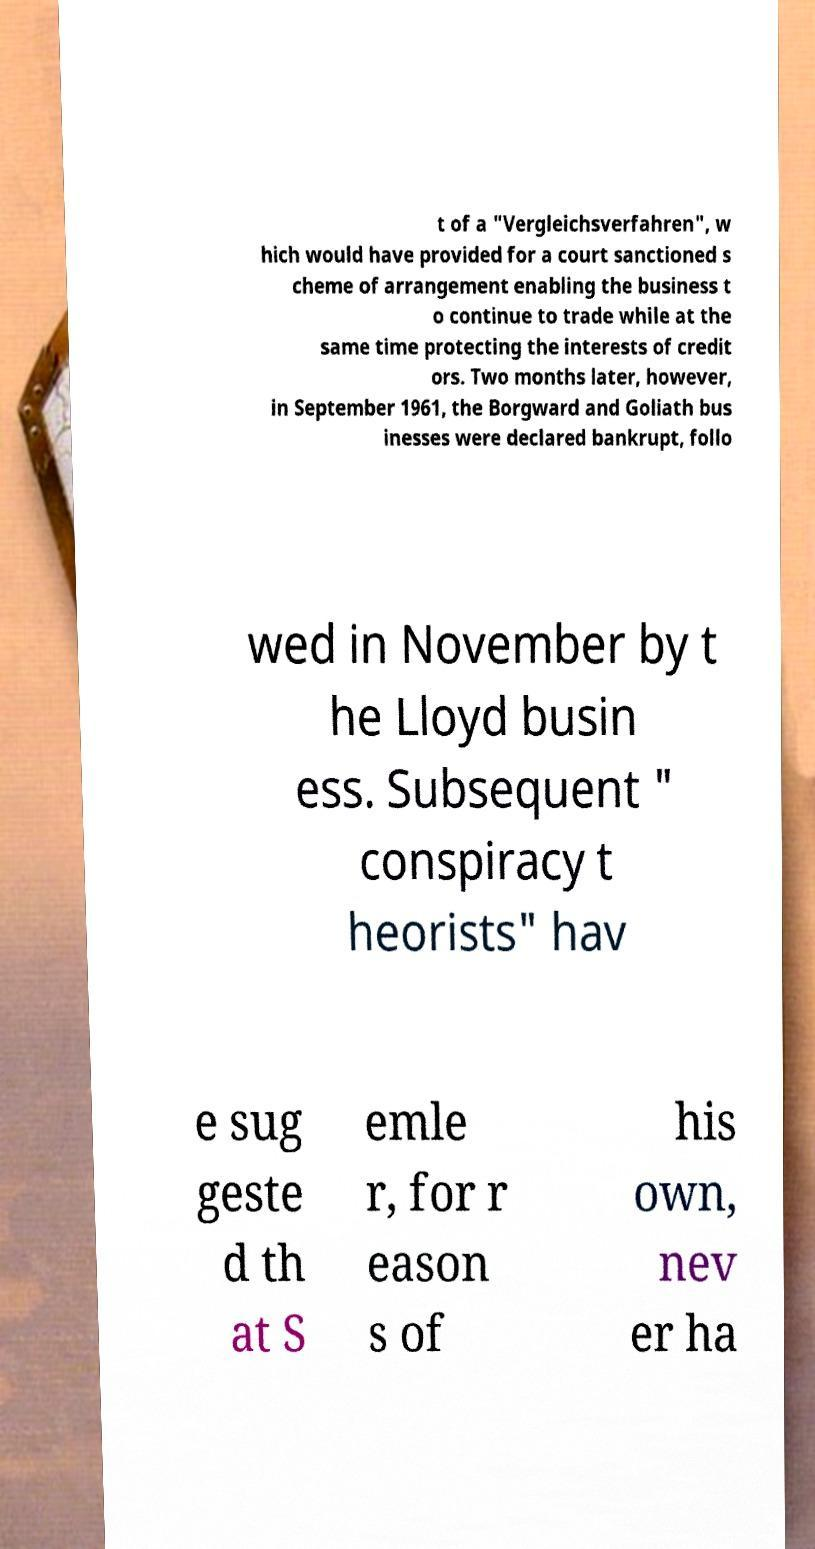Can you accurately transcribe the text from the provided image for me? t of a "Vergleichsverfahren", w hich would have provided for a court sanctioned s cheme of arrangement enabling the business t o continue to trade while at the same time protecting the interests of credit ors. Two months later, however, in September 1961, the Borgward and Goliath bus inesses were declared bankrupt, follo wed in November by t he Lloyd busin ess. Subsequent " conspiracy t heorists" hav e sug geste d th at S emle r, for r eason s of his own, nev er ha 